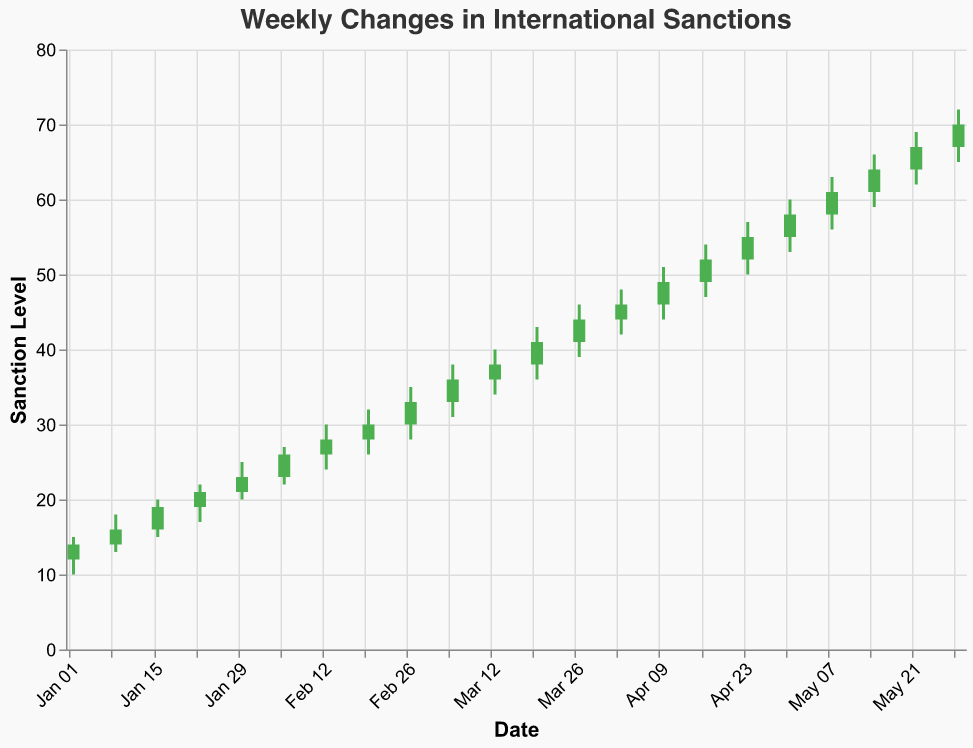What is the title of the chart? The title of the chart is typically displayed prominently at the top of the figure. In this case, based on the given data, the title is "Weekly Changes in International Sanctions".
Answer: Weekly Changes in International Sanctions What colors are used to differentiate between weeks where the closing value was higher than the opening value and weeks where it was not? The colors are used to indicate whether the closing value is higher or lower than the opening value. Green (#4CAF50) is used when the closing value is higher than the opening; red (#F44336) is used when the closing value is lower than the opening.
Answer: Green and Red What is the highest value reached in any week? The highest value, which corresponds to the "High" field, is found by looking for the maximum value in that column. The highest value is 72.
Answer: 72 What is the lowest closing value across all the weeks? To find the lowest closing value, we look through the "Close" values and identify the minimum. In this dataset, the lowest closing value is 14.
Answer: 14 How many weeks showed an increase in the closing value compared to the opening value? Weeks that show an increase in the closing value compared to the opening value are indicated by green bars. Counting the number of such occurrences in the dataset gives us 22 weeks.
Answer: 22 What is the total change in the closing value from the first week to the last week? Calculate the total change by subtracting the closing value of the first week from the closing value of the last week. So, 70 (last week) - 14 (first week) = 56.
Answer: 56 Which week had the smallest range between the high and low values? The range is calculated by subtracting the low value from the high value for each week. The smallest value is identified from these calculations. For example, 15-10=5 for Jan 2, 18-13=5 for Jan 9, and so on. The smallest range is 5 for Jan 2 and Jan 9 weeks.
Answer: Jan 2 and Jan 9 Which week had the largest increase in closing value compared to the previous week? To find the largest increase, we need to compute the difference between the closing values of consecutive weeks, and then find the maximum value of these differences. For example, the increase from Jan 2 (14) to Jan 9 (16) is 2, from Jan 9 (16) to Jan 16 (19) is 3, and so on. The largest increase is from Jan 16 (19) to Jan 23 (21), which is 3.
Answer: Jan 16 to Jan 23 How many weeks did the closing value decrease compared to the previous week? Determine the weeks where the closing value is less than the closing value of the previous week. By examining the dataset, no decreases are observed.
Answer: 0 Which month showed the highest average high value? Calculate the average high value for each month and compare them. January: (15+18+20+22+25)/5 = 20, February: (27+30+32+35)/4 = 31, March: (38+40+43+46)/4 = 42.25, April: (48+51+54)/3 = 51, May: (60+63+66+69+72)/5 = 66. The highest average is 66 in May.
Answer: May 